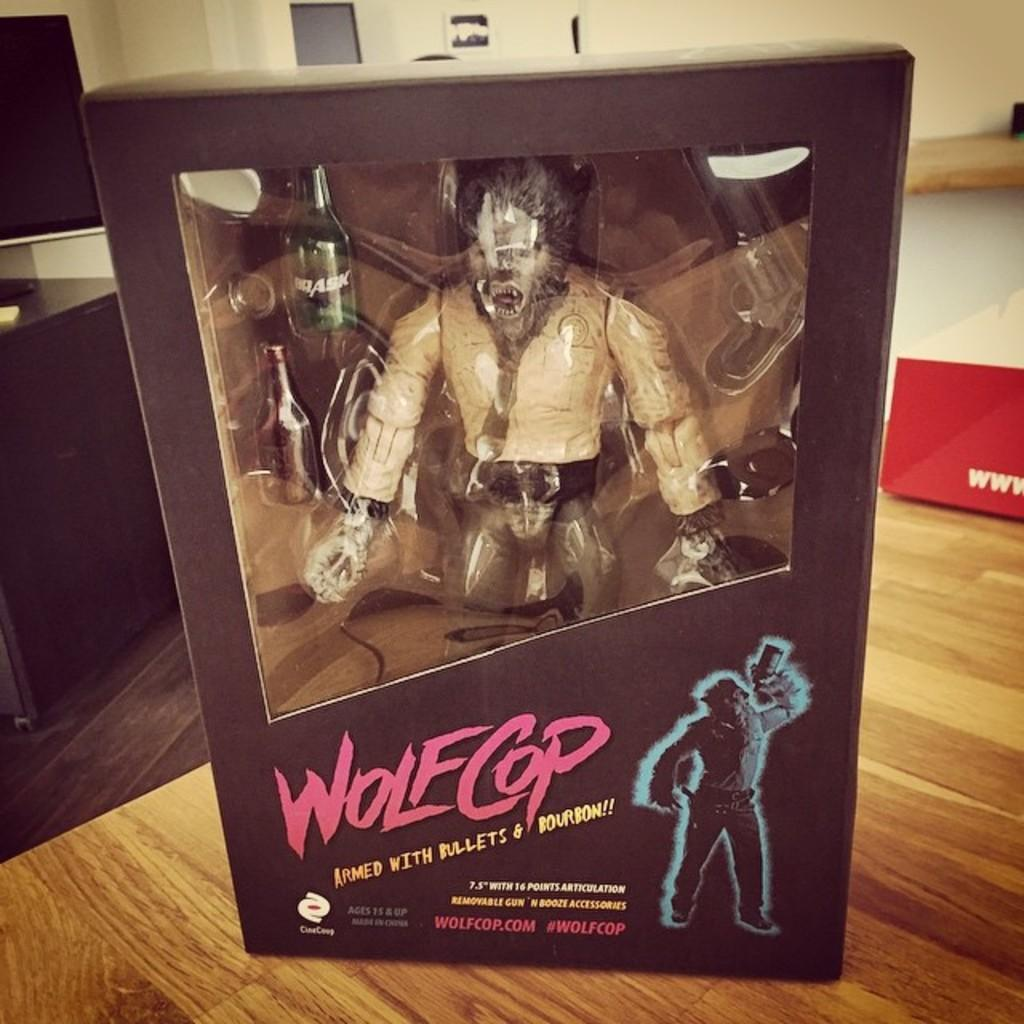<image>
Relay a brief, clear account of the picture shown. A Wolfcop toy sitting in the package on the table 